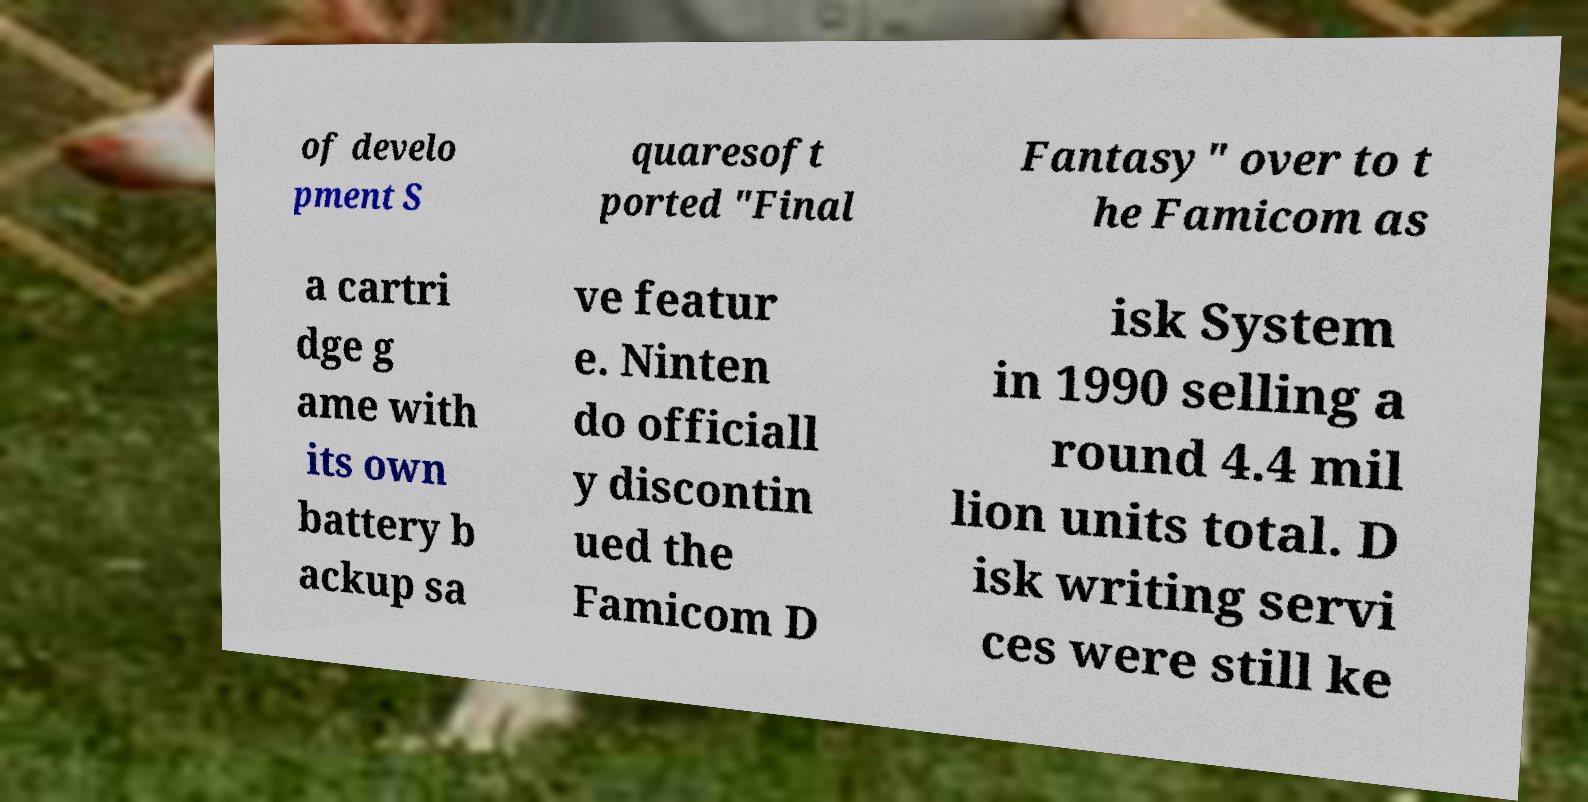I need the written content from this picture converted into text. Can you do that? of develo pment S quaresoft ported "Final Fantasy" over to t he Famicom as a cartri dge g ame with its own battery b ackup sa ve featur e. Ninten do officiall y discontin ued the Famicom D isk System in 1990 selling a round 4.4 mil lion units total. D isk writing servi ces were still ke 